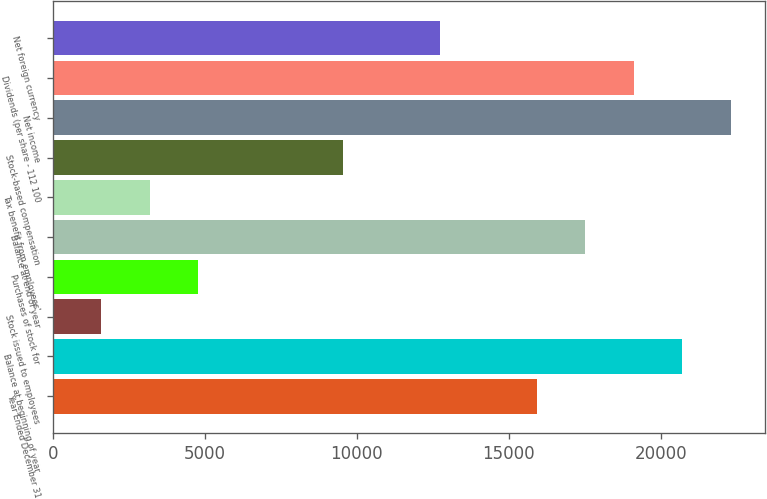Convert chart to OTSL. <chart><loc_0><loc_0><loc_500><loc_500><bar_chart><fcel>Year Ended December 31<fcel>Balance at beginning of year<fcel>Stock issued to employees<fcel>Purchases of stock for<fcel>Balance at end of year<fcel>Tax benefit from employees'<fcel>Stock-based compensation<fcel>Net income<fcel>Dividends (per share - 112 100<fcel>Net foreign currency<nl><fcel>15935<fcel>20714.6<fcel>1596.2<fcel>4782.6<fcel>17528.2<fcel>3189.4<fcel>9562.2<fcel>22307.8<fcel>19121.4<fcel>12748.6<nl></chart> 